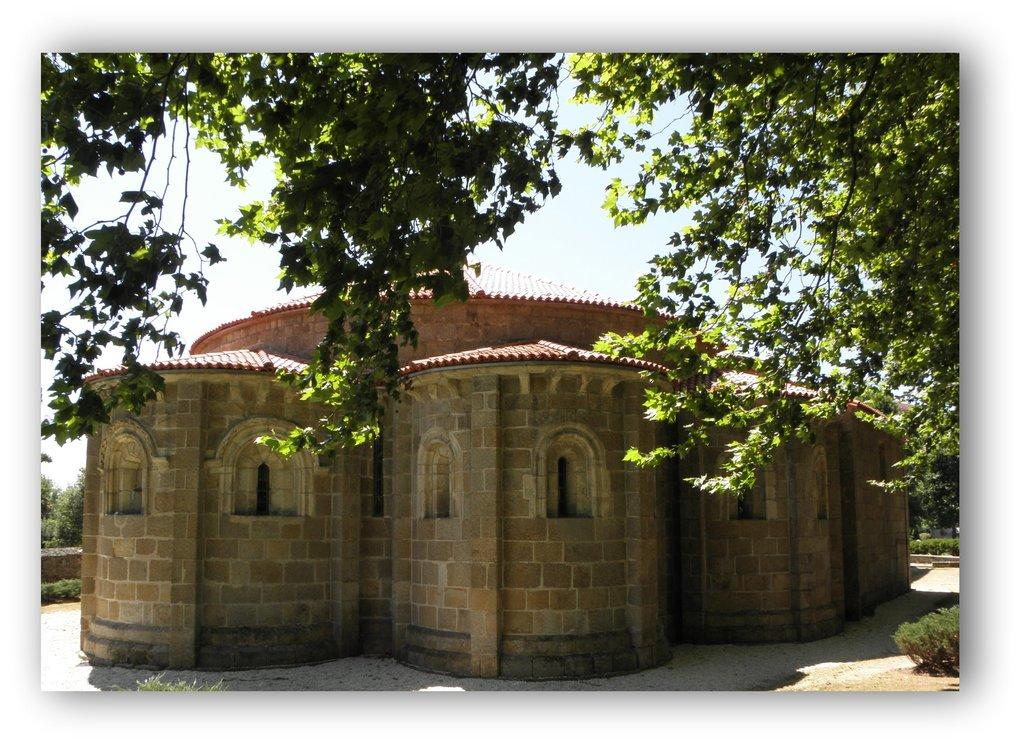What type of structure is present in the picture? There is a house in the picture. What other natural elements can be seen in the picture? There are plants and trees in the picture. What can be seen in the background of the picture? The sky is visible in the background of the picture. What type of wax can be seen dripping from the tongue of the dog in the picture? There is no dog or wax present in the picture; it features a house, plants, trees, and the sky. 